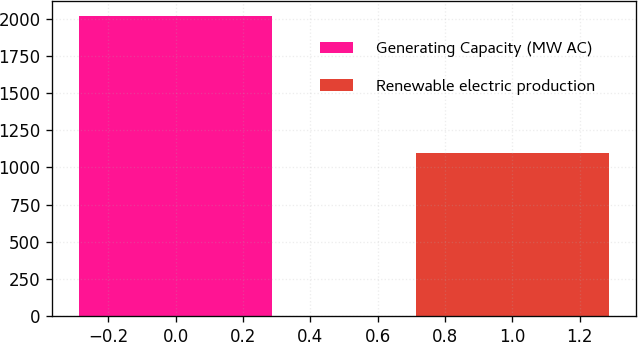Convert chart to OTSL. <chart><loc_0><loc_0><loc_500><loc_500><bar_chart><fcel>Generating Capacity (MW AC)<fcel>Renewable electric production<nl><fcel>2016<fcel>1098<nl></chart> 